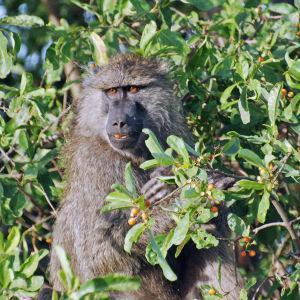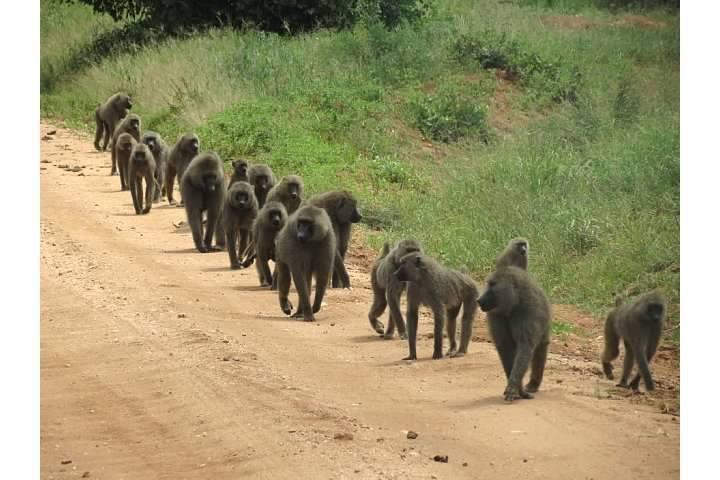The first image is the image on the left, the second image is the image on the right. For the images displayed, is the sentence "Left image shows one baboon, posed amid leafy foliage." factually correct? Answer yes or no. Yes. The first image is the image on the left, the second image is the image on the right. Assess this claim about the two images: "The image on the left shows a single chimp in the leaves of a tree.". Correct or not? Answer yes or no. Yes. 